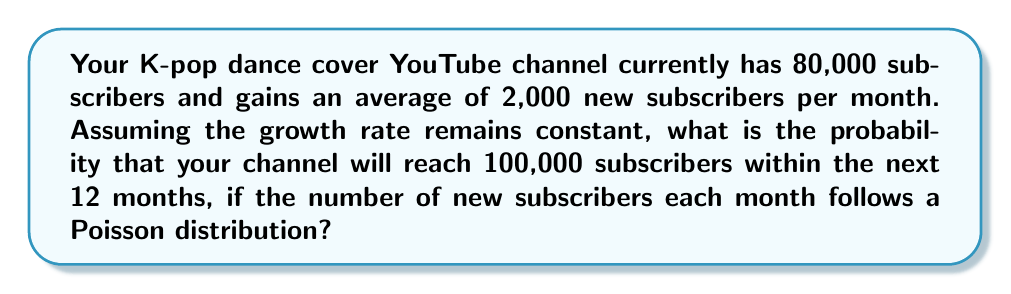Can you answer this question? Let's approach this step-by-step:

1) First, we need to calculate how many new subscribers are needed to reach 100,000:
   $100,000 - 80,000 = 20,000$ new subscribers needed

2) The average number of new subscribers per month is 2,000. In 12 months, the expected number of new subscribers is:
   $12 \times 2,000 = 24,000$

3) We can model this as a Poisson process. The probability of getting at least 20,000 new subscribers in 12 months is equivalent to the probability of not getting fewer than 20,000.

4) Let $X$ be the number of new subscribers in 12 months. $X$ follows a Poisson distribution with mean $\lambda = 24,000$.

5) We need to calculate $P(X \geq 20,000) = 1 - P(X < 20,000)$

6) For large $\lambda$, the Poisson distribution can be approximated by a normal distribution with mean $\mu = \lambda$ and standard deviation $\sigma = \sqrt{\lambda}$.

7) Applying the continuity correction:
   $P(X < 20,000) \approx P(Z < \frac{19999.5 - 24000}{\sqrt{24000}})$

   Where $Z$ is the standard normal variable.

8) Calculating the Z-score:
   $Z = \frac{19999.5 - 24000}{\sqrt{24000}} \approx -8.17$

9) Using a standard normal table or calculator:
   $P(Z < -8.17) \approx 0$

10) Therefore, $P(X \geq 20,000) = 1 - P(X < 20,000) \approx 1 - 0 = 1$
Answer: $\approx 1$ or $99.99\%$ 